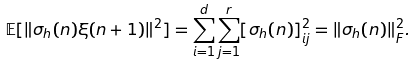<formula> <loc_0><loc_0><loc_500><loc_500>\mathbb { E } [ \| \sigma _ { h } ( n ) \xi ( n + 1 ) \| ^ { 2 } ] = \sum _ { i = 1 } ^ { d } \sum _ { j = 1 } ^ { r } [ \sigma _ { h } ( n ) ] _ { i j } ^ { 2 } = \| \sigma _ { h } ( n ) \| _ { F } ^ { 2 } .</formula> 